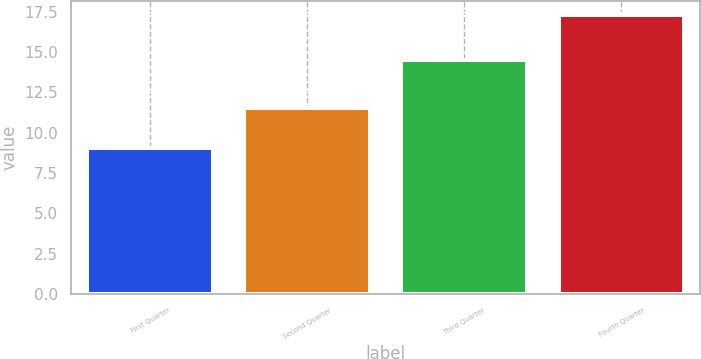Convert chart to OTSL. <chart><loc_0><loc_0><loc_500><loc_500><bar_chart><fcel>First Quarter<fcel>Second Quarter<fcel>Third Quarter<fcel>Fourth Quarter<nl><fcel>9.07<fcel>11.54<fcel>14.5<fcel>17.28<nl></chart> 